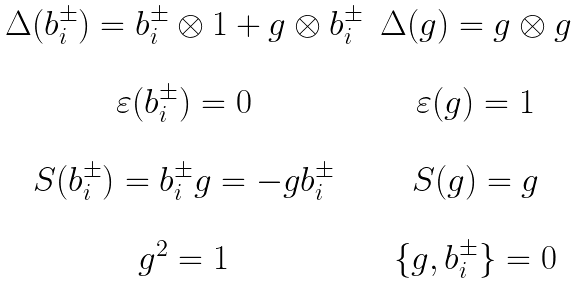<formula> <loc_0><loc_0><loc_500><loc_500>\begin{array} { c c } \Delta ( b _ { i } ^ { \pm } ) = b _ { i } ^ { \pm } \otimes 1 + g \otimes b _ { i } ^ { \pm } & \Delta ( g ) = g \otimes g \\ \\ \varepsilon ( b _ { i } ^ { \pm } ) = 0 & \varepsilon ( g ) = 1 \\ \\ S ( b _ { i } ^ { \pm } ) = b _ { i } ^ { \pm } g = - g b _ { i } ^ { \pm } & S ( g ) = g \\ \\ g ^ { 2 } = 1 & \{ g , b _ { i } ^ { \pm } \} = 0 \\ \end{array}</formula> 